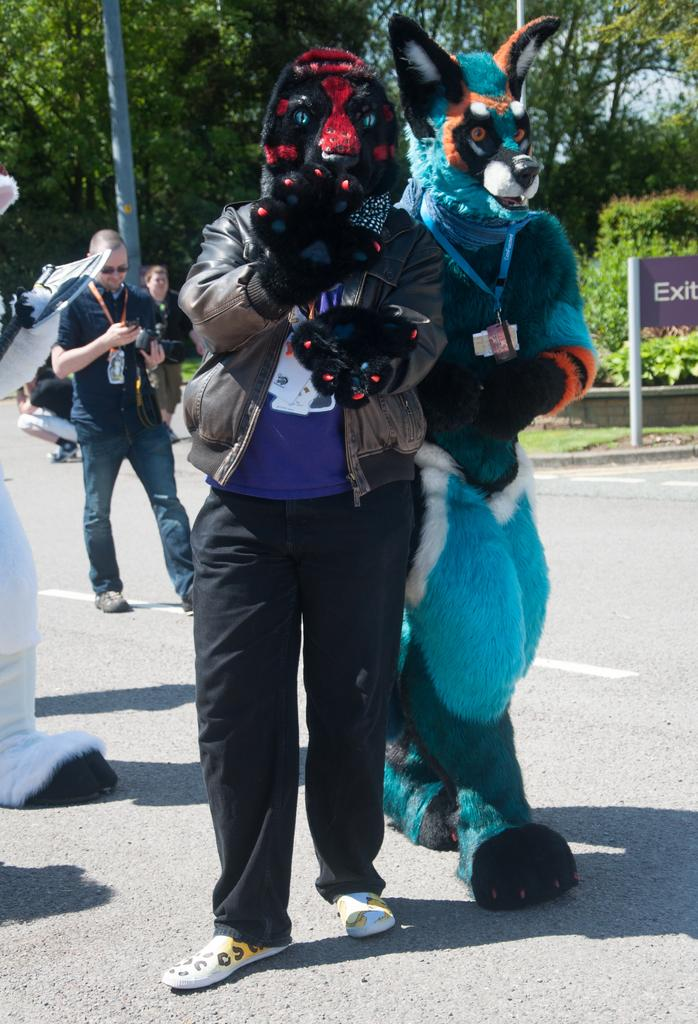What are the two men wearing in the image? The two men are wearing fox costumes in the image. What are the men doing while wearing the costumes? The men are walking on the road while wearing the costumes. What is the man in the background doing? The man in the background is standing and looking at a mobile. What can be seen in the distance in the image? There are trees visible in the background of the image. How many dolls are sitting on the bench in the image? There are no dolls present in the image; it features two men wearing fox costumes and a man looking at a mobile. Are the two men wearing fox costumes brothers? The facts provided do not mention any familial relationship between the two men wearing fox costumes, so we cannot determine if they are brothers. 